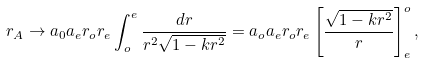<formula> <loc_0><loc_0><loc_500><loc_500>r _ { A } \rightarrow a _ { 0 } a _ { e } r _ { o } r _ { e } \int _ { o } ^ { e } \frac { d r } { r ^ { 2 } \sqrt { 1 - k r ^ { 2 } } } = a _ { o } a _ { e } r _ { o } r _ { e } \left [ \frac { \sqrt { 1 - k r ^ { 2 } } } { r } \right ] ^ { o } _ { e } ,</formula> 